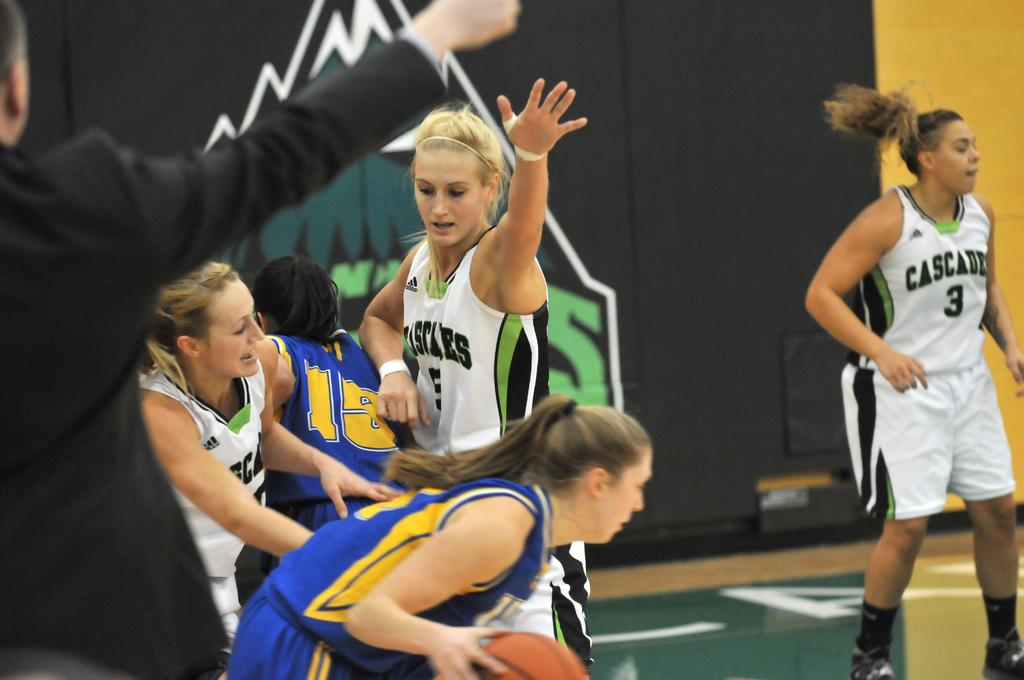What activity are the girls in the image participating in? The girls in the image are playing basketball. Can you describe the man's position in the image? The man is standing on the left side of the image. What school is the man guiding the girls to in the image? There is no school or guiding activity present in the image. 